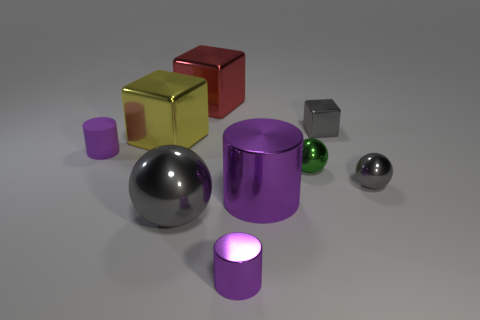The tiny cylinder behind the tiny gray shiny thing that is in front of the large yellow shiny cube is what color?
Make the answer very short. Purple. What number of spheres are both in front of the tiny green thing and to the right of the small purple metal cylinder?
Keep it short and to the point. 1. How many large gray objects have the same shape as the tiny green shiny thing?
Make the answer very short. 1. Do the big red object and the green ball have the same material?
Provide a succinct answer. Yes. There is a gray object that is in front of the large object on the right side of the large red cube; what shape is it?
Offer a terse response. Sphere. There is a small metal object that is behind the small purple rubber thing; how many big yellow metallic objects are right of it?
Offer a terse response. 0. There is a thing that is both left of the large red object and in front of the small purple matte object; what material is it?
Provide a succinct answer. Metal. The green thing that is the same size as the purple rubber cylinder is what shape?
Provide a short and direct response. Sphere. There is a small metal sphere that is to the left of the gray metal object behind the purple thing left of the big ball; what color is it?
Ensure brevity in your answer.  Green. What number of objects are either shiny blocks behind the tiny metal cube or purple rubber things?
Offer a terse response. 2. 